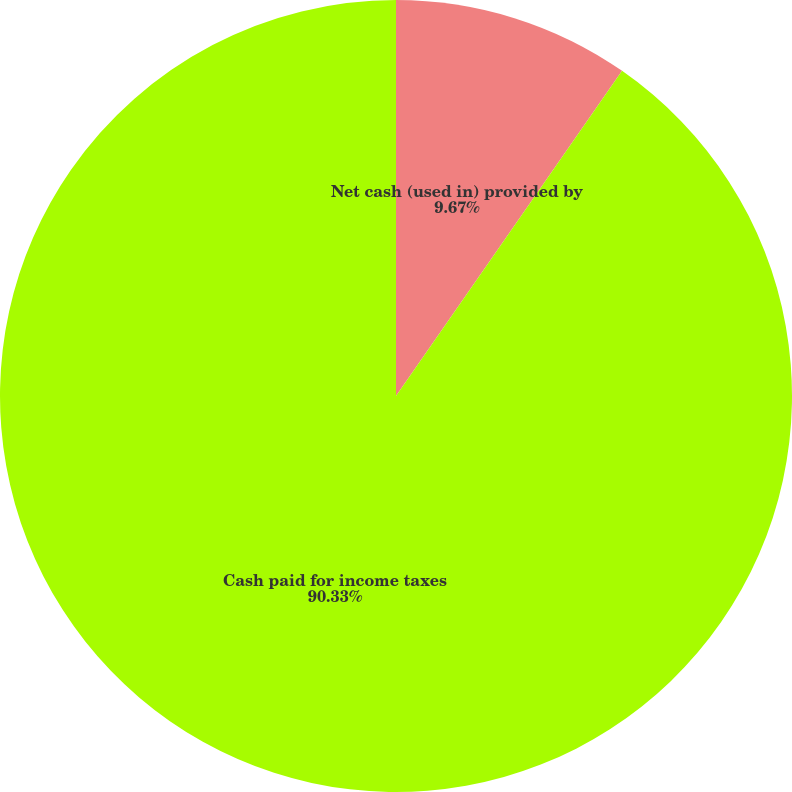Convert chart to OTSL. <chart><loc_0><loc_0><loc_500><loc_500><pie_chart><fcel>Net cash (used in) provided by<fcel>Cash paid for income taxes<nl><fcel>9.67%<fcel>90.33%<nl></chart> 